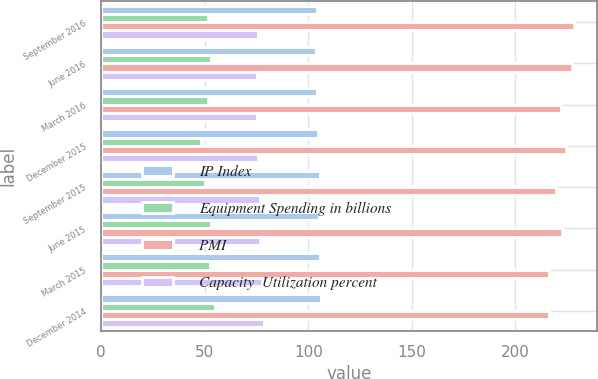Convert chart to OTSL. <chart><loc_0><loc_0><loc_500><loc_500><stacked_bar_chart><ecel><fcel>September 2016<fcel>June 2016<fcel>March 2016<fcel>December 2015<fcel>September 2015<fcel>June 2015<fcel>March 2015<fcel>December 2014<nl><fcel>IP Index<fcel>104.4<fcel>103.9<fcel>104.1<fcel>104.6<fcel>105.5<fcel>105.1<fcel>105.8<fcel>106.3<nl><fcel>Equipment Spending in billions<fcel>51.5<fcel>53.2<fcel>51.8<fcel>48<fcel>50<fcel>53.1<fcel>52.3<fcel>55.1<nl><fcel>PMI<fcel>228.2<fcel>227.3<fcel>222.2<fcel>224.7<fcel>219.8<fcel>222.7<fcel>216.4<fcel>216.5<nl><fcel>Capacity  Utilization percent<fcel>75.5<fcel>75.2<fcel>75.4<fcel>75.8<fcel>76.6<fcel>76.6<fcel>77.7<fcel>78.6<nl></chart> 